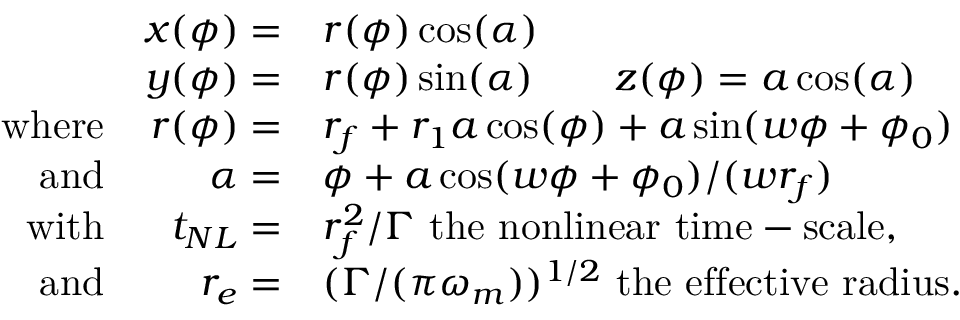<formula> <loc_0><loc_0><loc_500><loc_500>\begin{array} { r r l } & { x ( \phi ) = } & { r ( \phi ) \cos ( \alpha ) } \\ & { y ( \phi ) = } & { r ( \phi ) \sin ( \alpha ) \quad z ( \phi ) = a \cos ( \alpha ) } \\ { w h e r e } & { r ( \phi ) = } & { r _ { f } + r _ { 1 } a \cos ( \phi ) + a \sin ( w \phi + \phi _ { 0 } ) } \\ { a n d } & { \alpha = } & { \phi + a \cos ( w \phi + \phi _ { 0 } ) / ( w r _ { f } ) } \\ { w i t h } & { t _ { N L } = } & { r _ { f } ^ { 2 } / \Gamma t h e n o n l i n e a r t i m e - s c a l e , } \\ { a n d } & { r _ { e } = } & { ( \Gamma / ( \pi \omega _ { m } ) ) ^ { 1 / 2 } t h e e f f e c t i v e r a d i u s . } \end{array}</formula> 